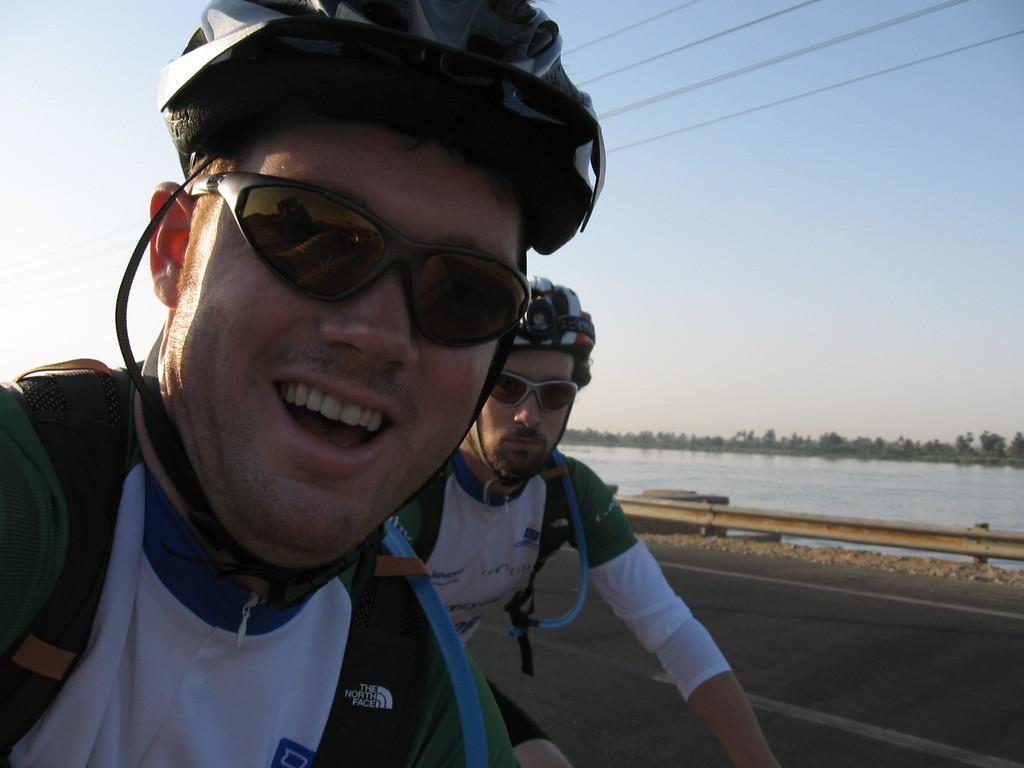How many people are riding the bicycle in the image? There are two people riding the bicycle in the image. Where is the bicycle located? The bicycle is on the road in the image. What can be seen in the background of the image? In the background of the image, there is a railing, water, sky, and wires. What type of notebook is the squirrel holding while riding the bicycle in the image? There is no squirrel or notebook present in the image. What type of harmony is being displayed by the people riding the bicycle in the image? The image does not depict any specific harmony or emotion; it simply shows two people riding a bicycle. 